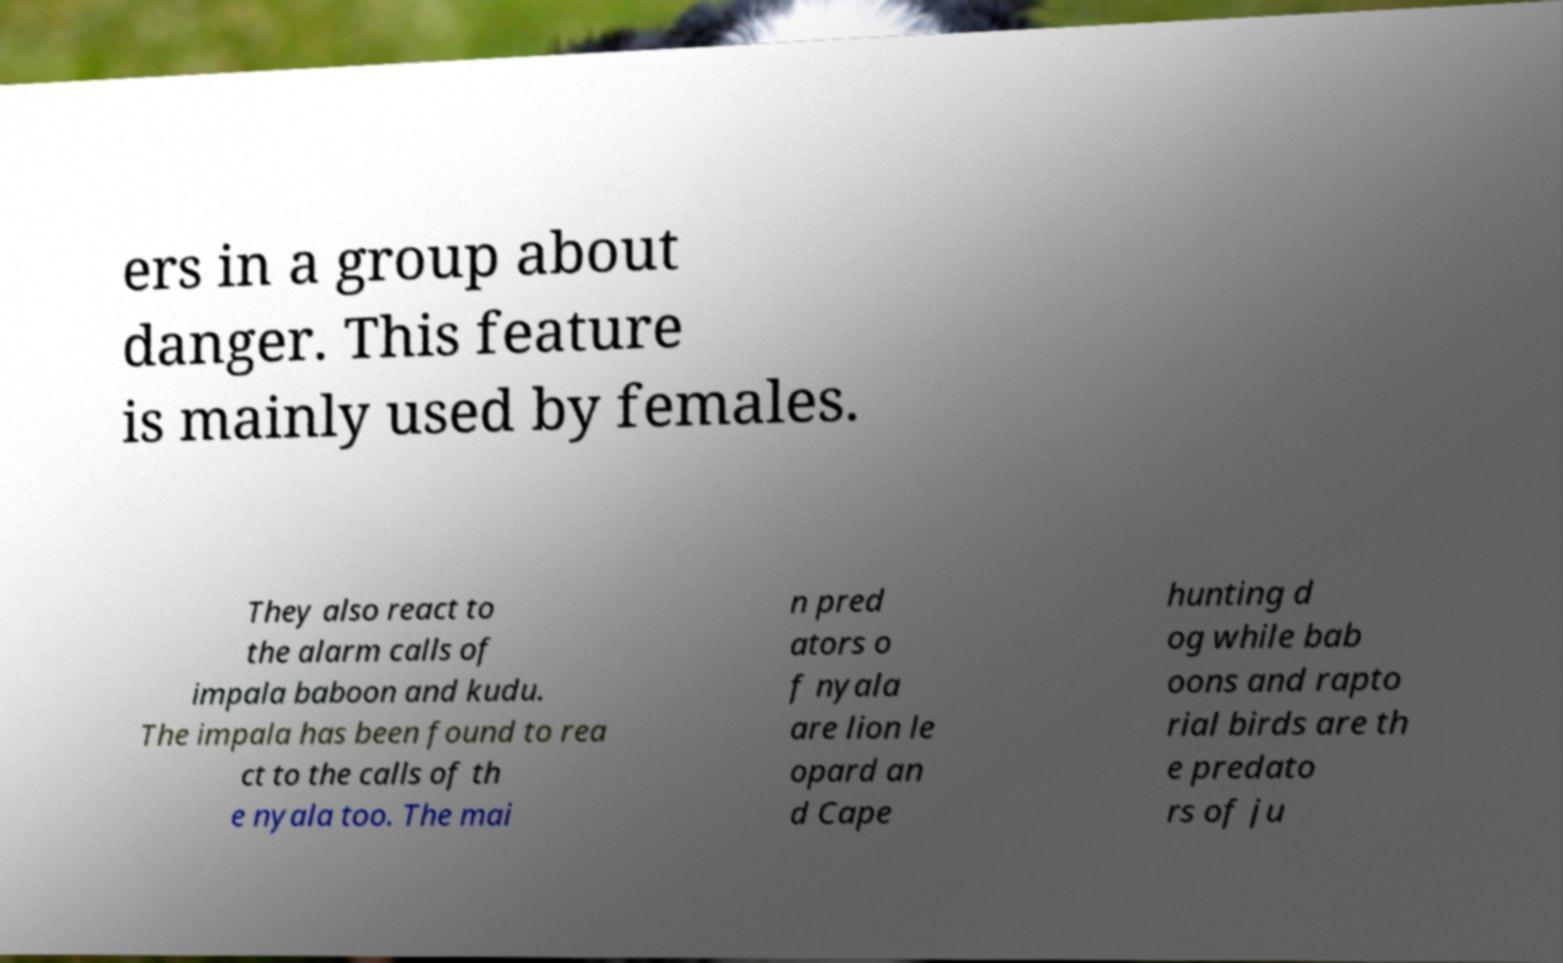Can you accurately transcribe the text from the provided image for me? ers in a group about danger. This feature is mainly used by females. They also react to the alarm calls of impala baboon and kudu. The impala has been found to rea ct to the calls of th e nyala too. The mai n pred ators o f nyala are lion le opard an d Cape hunting d og while bab oons and rapto rial birds are th e predato rs of ju 